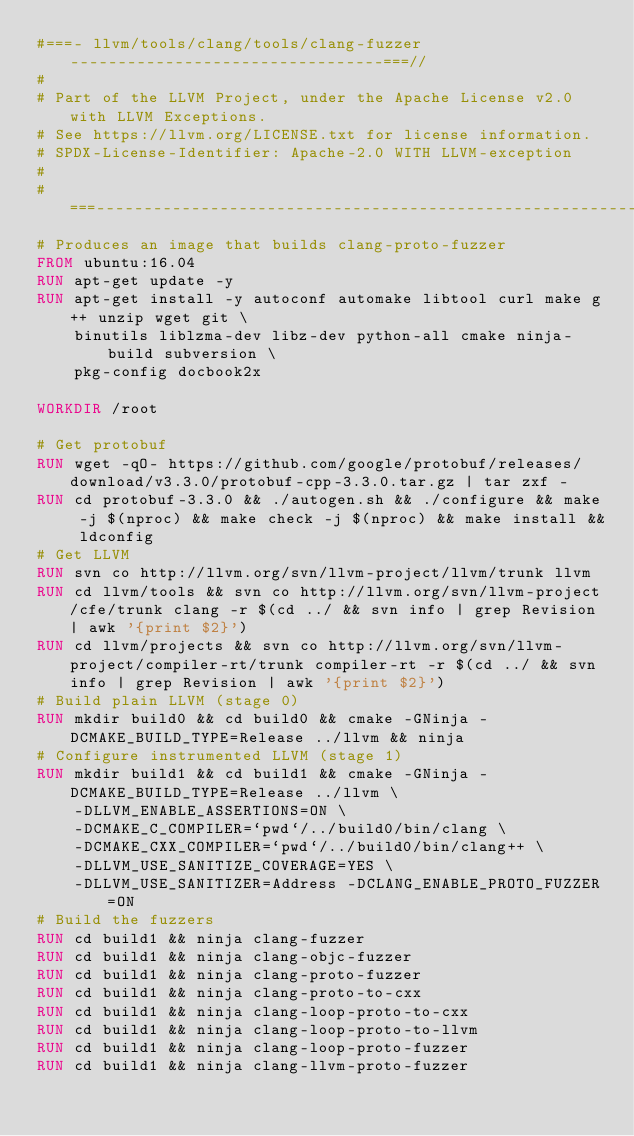Convert code to text. <code><loc_0><loc_0><loc_500><loc_500><_Dockerfile_>#===- llvm/tools/clang/tools/clang-fuzzer ---------------------------------===//
#
# Part of the LLVM Project, under the Apache License v2.0 with LLVM Exceptions.
# See https://llvm.org/LICENSE.txt for license information.
# SPDX-License-Identifier: Apache-2.0 WITH LLVM-exception
#
#===----------------------------------------------------------------------===//
# Produces an image that builds clang-proto-fuzzer
FROM ubuntu:16.04
RUN apt-get update -y
RUN apt-get install -y autoconf automake libtool curl make g++ unzip wget git \
    binutils liblzma-dev libz-dev python-all cmake ninja-build subversion \
    pkg-config docbook2x

WORKDIR /root

# Get protobuf
RUN wget -qO- https://github.com/google/protobuf/releases/download/v3.3.0/protobuf-cpp-3.3.0.tar.gz | tar zxf -
RUN cd protobuf-3.3.0 && ./autogen.sh && ./configure && make -j $(nproc) && make check -j $(nproc) && make install && ldconfig
# Get LLVM
RUN svn co http://llvm.org/svn/llvm-project/llvm/trunk llvm
RUN cd llvm/tools && svn co http://llvm.org/svn/llvm-project/cfe/trunk clang -r $(cd ../ && svn info | grep Revision | awk '{print $2}')
RUN cd llvm/projects && svn co http://llvm.org/svn/llvm-project/compiler-rt/trunk compiler-rt -r $(cd ../ && svn info | grep Revision | awk '{print $2}')
# Build plain LLVM (stage 0)
RUN mkdir build0 && cd build0 && cmake -GNinja -DCMAKE_BUILD_TYPE=Release ../llvm && ninja
# Configure instrumented LLVM (stage 1)
RUN mkdir build1 && cd build1 && cmake -GNinja -DCMAKE_BUILD_TYPE=Release ../llvm \
    -DLLVM_ENABLE_ASSERTIONS=ON \
    -DCMAKE_C_COMPILER=`pwd`/../build0/bin/clang \
    -DCMAKE_CXX_COMPILER=`pwd`/../build0/bin/clang++ \
    -DLLVM_USE_SANITIZE_COVERAGE=YES \
    -DLLVM_USE_SANITIZER=Address -DCLANG_ENABLE_PROTO_FUZZER=ON
# Build the fuzzers
RUN cd build1 && ninja clang-fuzzer
RUN cd build1 && ninja clang-objc-fuzzer
RUN cd build1 && ninja clang-proto-fuzzer
RUN cd build1 && ninja clang-proto-to-cxx
RUN cd build1 && ninja clang-loop-proto-to-cxx
RUN cd build1 && ninja clang-loop-proto-to-llvm
RUN cd build1 && ninja clang-loop-proto-fuzzer
RUN cd build1 && ninja clang-llvm-proto-fuzzer
</code> 